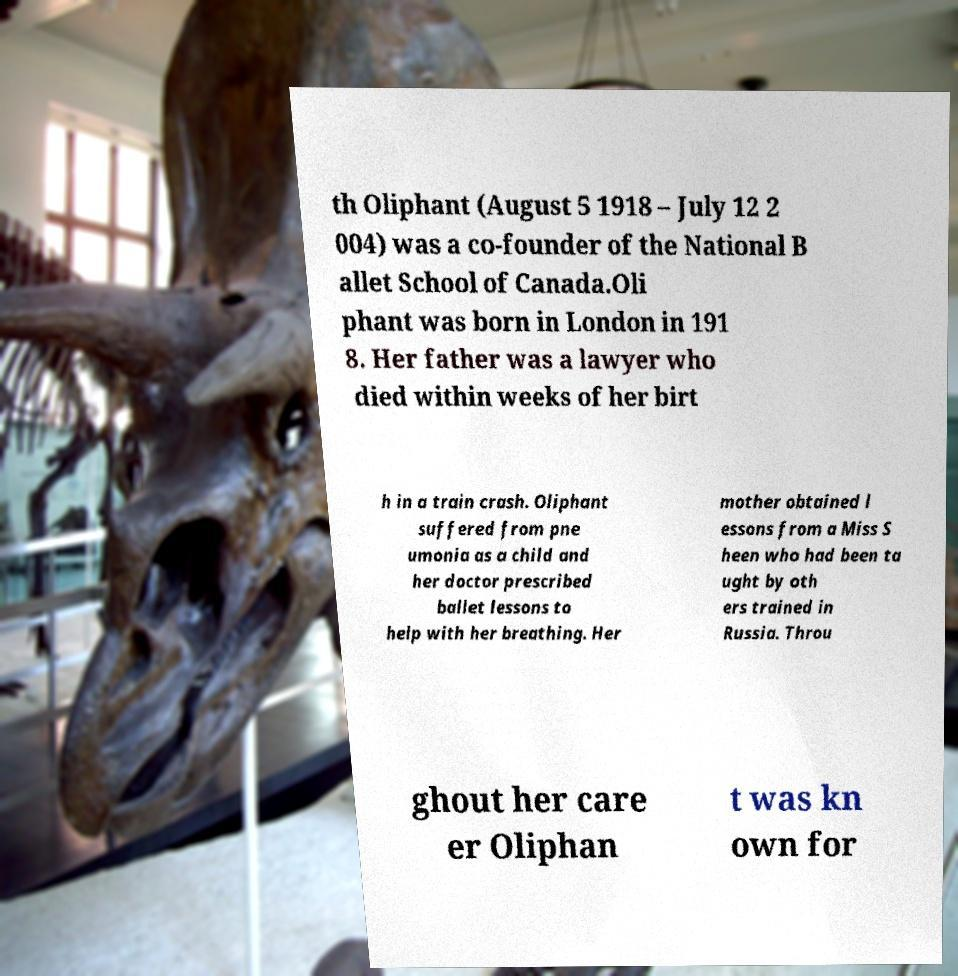I need the written content from this picture converted into text. Can you do that? th Oliphant (August 5 1918 – July 12 2 004) was a co-founder of the National B allet School of Canada.Oli phant was born in London in 191 8. Her father was a lawyer who died within weeks of her birt h in a train crash. Oliphant suffered from pne umonia as a child and her doctor prescribed ballet lessons to help with her breathing. Her mother obtained l essons from a Miss S heen who had been ta ught by oth ers trained in Russia. Throu ghout her care er Oliphan t was kn own for 